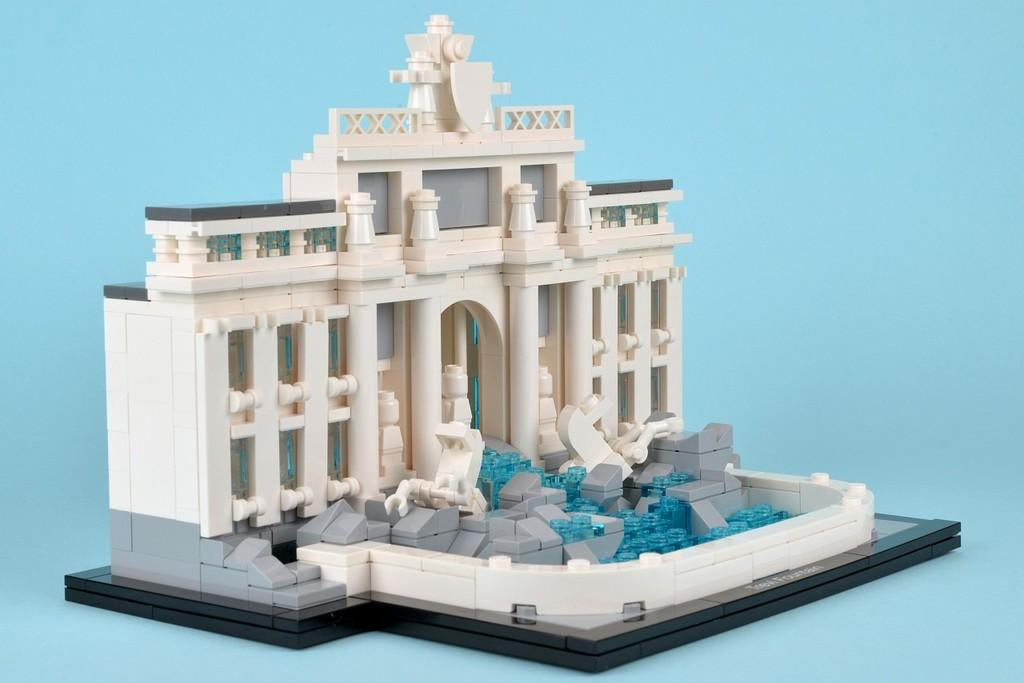What type of toy is present in the image? There is a toy house in the image. What is the color of the surface on which the toy house is placed? The toy house is on a blue surface. Can you see a railway connecting the toy house to another structure in the image? There is no railway present in the image; it only features a toy house on a blue surface. 